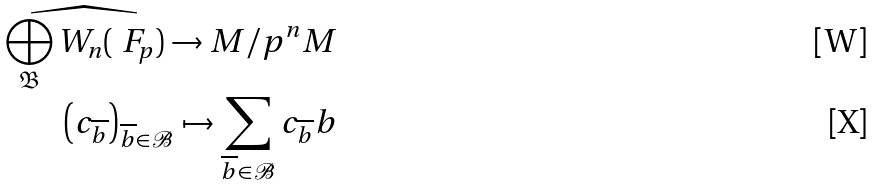Convert formula to latex. <formula><loc_0><loc_0><loc_500><loc_500>\widehat { \bigoplus _ { \mathfrak { B } } W _ { n } ( \ F _ { p } ) } \to M / p ^ { n } M \\ \left ( c _ { \overline { b } } \right ) _ { \overline { b } \in \mathcal { B } } \mapsto \sum _ { \overline { b } \in \mathcal { B } } c _ { \overline { b } } b</formula> 